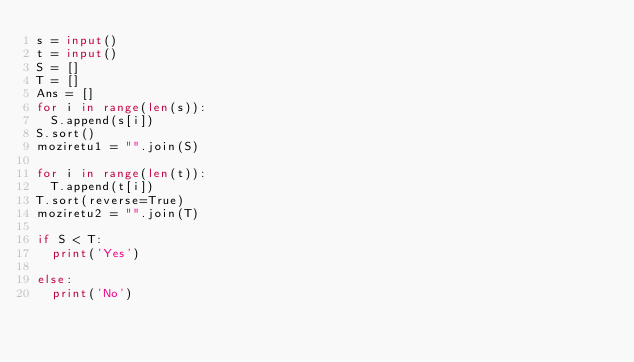<code> <loc_0><loc_0><loc_500><loc_500><_Python_>s = input()
t = input()
S = []
T = []
Ans = []
for i in range(len(s)):
	S.append(s[i])
S.sort()
moziretu1 = "".join(S)

for i in range(len(t)):
	T.append(t[i])
T.sort(reverse=True)
moziretu2 = "".join(T)

if S < T:
	print('Yes')

else:
	print('No')
	</code> 